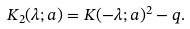<formula> <loc_0><loc_0><loc_500><loc_500>K _ { 2 } ( \lambda ; a ) = K ( - \lambda ; a ) ^ { 2 } - q .</formula> 